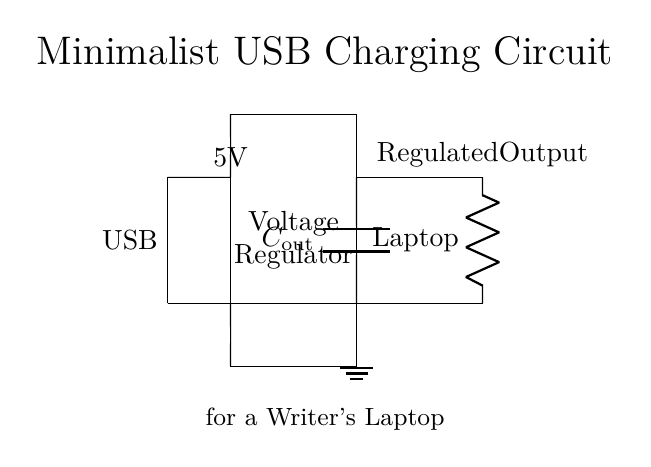What is the input type for this circuit? The input type is USB, as indicated by the label on the left side of the circuit diagram.
Answer: USB What is the output voltage of the circuit? The output voltage is 5V, which is marked above the voltage regulator in the diagram.
Answer: 5V What component regulates the voltage in this circuit? The component that regulates the voltage is the voltage regulator, shown as a rectangle in the circuit.
Answer: Voltage regulator What is the purpose of the capacitor in this circuit? The capacitor, labeled as C_out, is used for smoothing the output voltage and ensuring stability in the circuit's operation.
Answer: Smoothing Which component represents the writer's laptop in this circuit? The writer's laptop is represented by the resistor labeled "Laptop," located on the right side of the circuit.
Answer: Laptop What is connected to the ground in this circuit? The ground is connected to the short line at the bottom, which indicates the reference point for voltage measurements; it connects to the circuit near the output section.
Answer: Output section Why is a voltage regulator used in this circuit? The voltage regulator is used to maintain a consistent output voltage of 5V, regardless of variations in input voltage or load conditions, ensuring the laptop receives stable power.
Answer: Maintain consistent voltage 